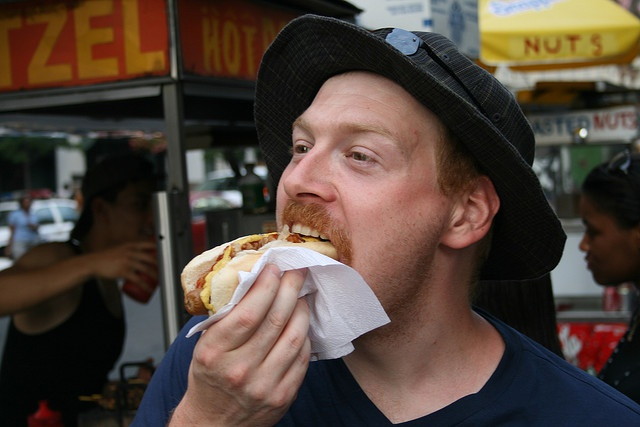Describe the objects in this image and their specific colors. I can see people in black, brown, maroon, and lightpink tones, people in black, maroon, and gray tones, people in black, maroon, gray, and darkgreen tones, hot dog in black, tan, and lightgray tones, and car in black, darkgray, and gray tones in this image. 